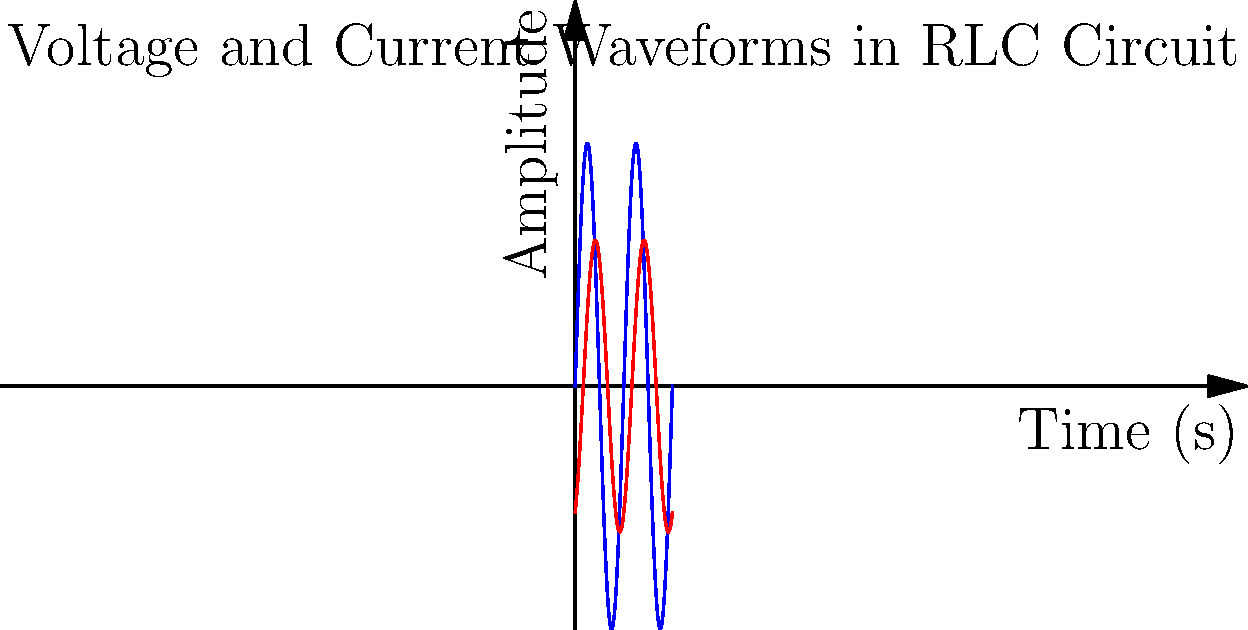In the given RLC circuit, the voltage and current waveforms are shown. The blue curve represents the voltage, and the red curve represents the current. What is the phase difference between the voltage and current, and what does this indicate about the circuit's behavior? To determine the phase difference and circuit behavior, let's follow these steps:

1. Observe the waveforms:
   - Blue curve (voltage): $V(t) = 5\sin(2\pi t)$
   - Red curve (current): $I(t) = 3\sin(2\pi t - \phi)$, where $\phi$ is the phase difference

2. Identify the phase shift:
   - The current waveform lags behind the voltage waveform
   - The phase difference appears to be $\pi/3$ or 60°

3. Interpret the phase difference:
   - In an RLC circuit, when current lags voltage, it indicates an inductive behavior
   - The phase difference of 60° suggests a mix of resistive and inductive elements

4. Circuit analysis:
   - Pure resistive circuit: 0° phase difference
   - Pure inductive circuit: 90° phase difference
   - Pure capacitive circuit: -90° phase difference

5. Conclusion:
   - The 60° phase difference indicates that the circuit is predominantly inductive
   - There is also a significant resistive component present
   - The capacitive effect is less dominant in this circuit
Answer: 60° phase difference; predominantly inductive behavior 